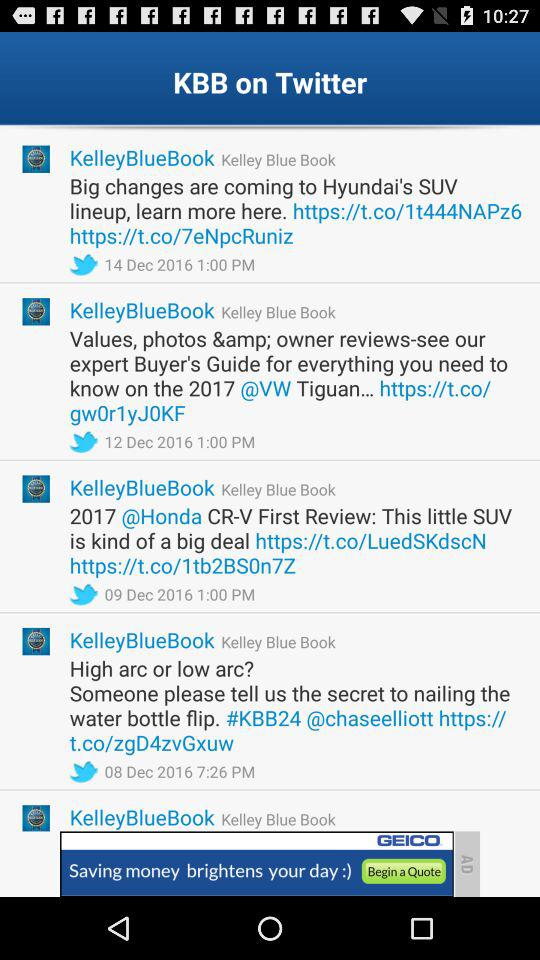What is the Manufacturer's Suggested Retail Price for the 2017 Acura ILX? The Manufacturer's Suggested Retail Price for the 2017 Acura ILX is $28,930. 